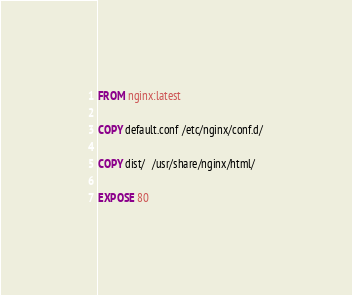<code> <loc_0><loc_0><loc_500><loc_500><_Dockerfile_>FROM nginx:latest

COPY default.conf /etc/nginx/conf.d/

COPY dist/  /usr/share/nginx/html/

EXPOSE 80</code> 